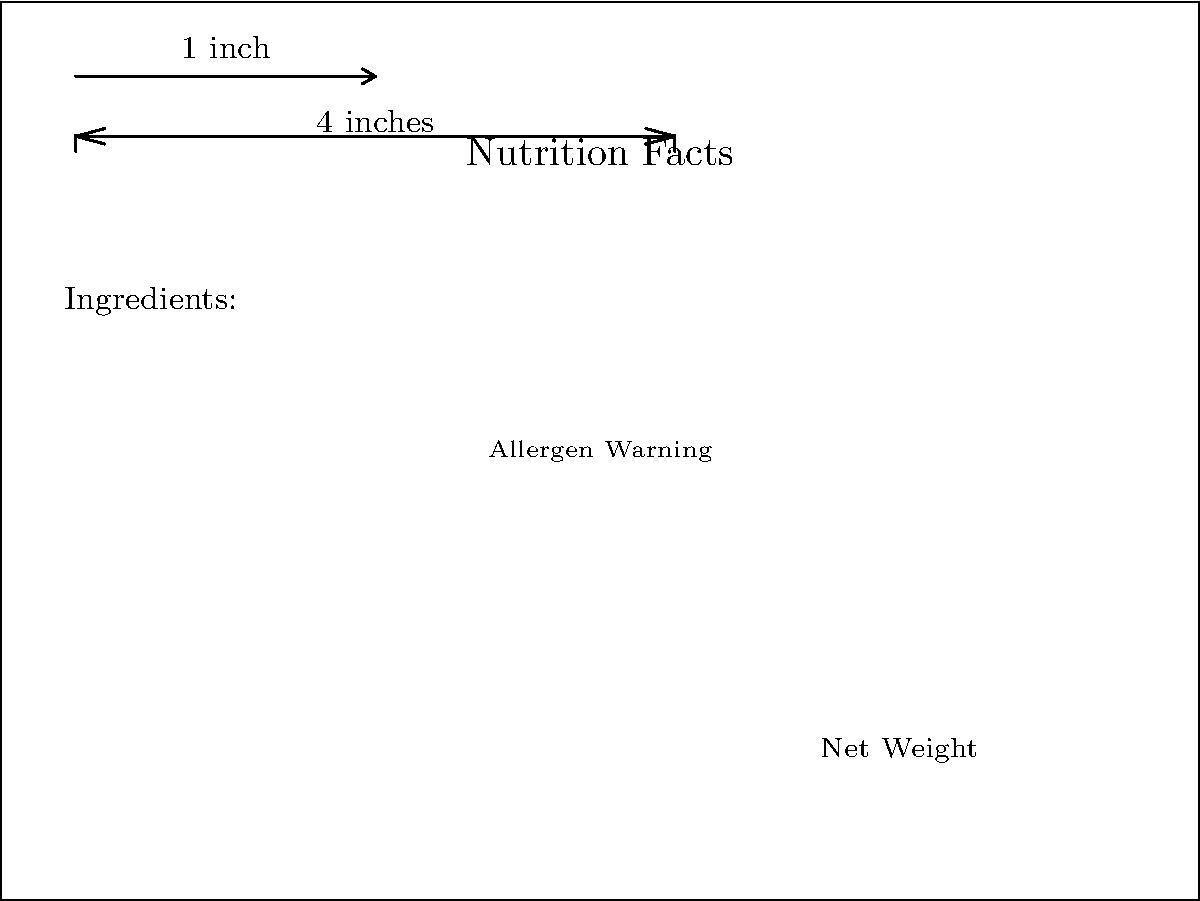Based on the package design shown, which label element does not meet the minimum text size requirement of 1/16 inch (equivalent to 6 points) for easy readability? To determine which label element does not meet the minimum text size requirement, we need to follow these steps:

1. Identify the reference scale: The image shows a 1-inch reference scale.

2. Understand the minimum requirement: The minimum text size requirement is 1/16 inch, which is equivalent to 6 points.

3. Visually compare the text sizes:
   a. "Nutrition Facts" appears to be larger than 6 points
   b. "Ingredients:" appears to be larger than 6 points
   c. "Allergen Warning" appears to be smaller than or equal to 6 points
   d. "Net Weight" appears to be slightly larger than 6 points

4. Use the reference scale to estimate sizes:
   The "Nutrition Facts" text spans about 4 inches, which is much larger than 1/16 inch.
   The "Allergen Warning" text is noticeably smaller than the other elements.

5. Conclusion: The "Allergen Warning" text appears to be the only element that may not meet the minimum size requirement of 1/16 inch (6 points).
Answer: Allergen Warning 